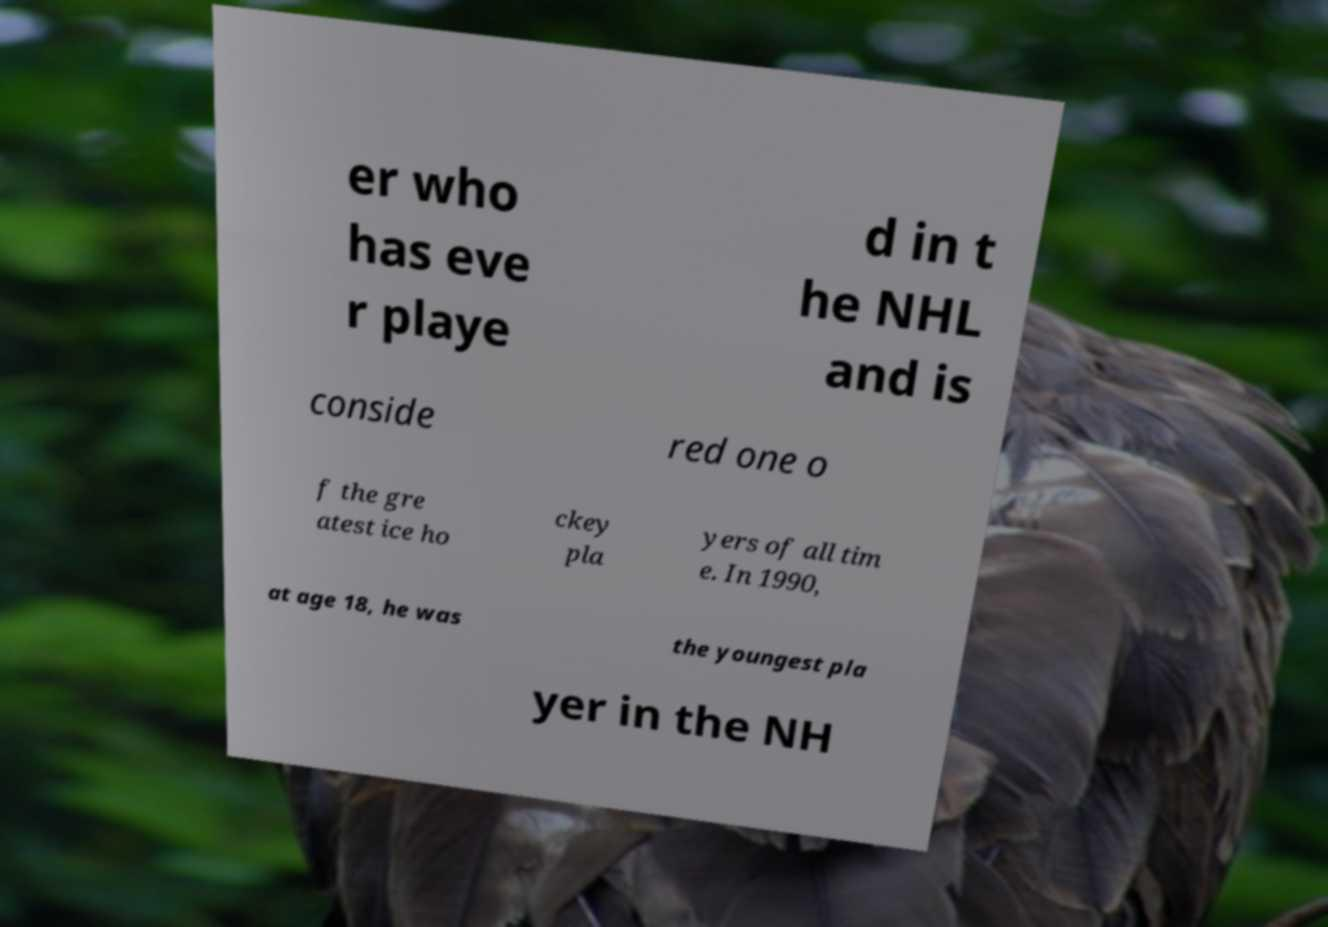Could you assist in decoding the text presented in this image and type it out clearly? er who has eve r playe d in t he NHL and is conside red one o f the gre atest ice ho ckey pla yers of all tim e. In 1990, at age 18, he was the youngest pla yer in the NH 